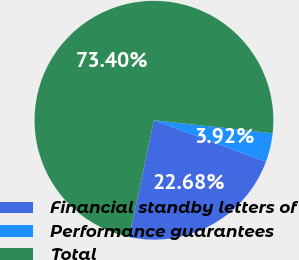Convert chart to OTSL. <chart><loc_0><loc_0><loc_500><loc_500><pie_chart><fcel>Financial standby letters of<fcel>Performance guarantees<fcel>Total<nl><fcel>22.68%<fcel>3.92%<fcel>73.4%<nl></chart> 